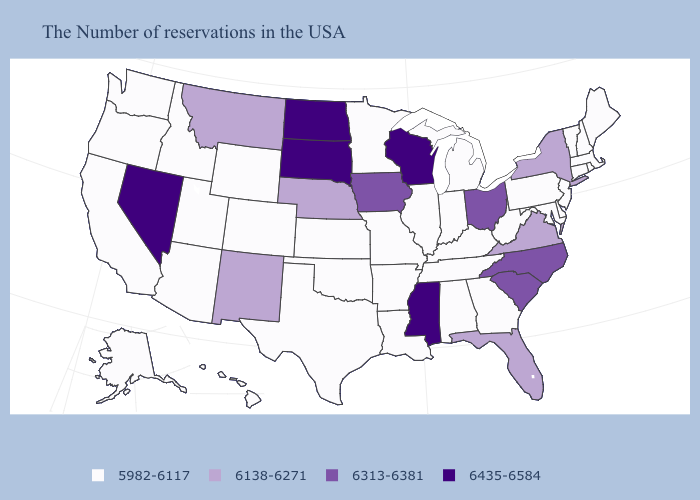Name the states that have a value in the range 5982-6117?
Keep it brief. Maine, Massachusetts, Rhode Island, New Hampshire, Vermont, Connecticut, New Jersey, Delaware, Maryland, Pennsylvania, West Virginia, Georgia, Michigan, Kentucky, Indiana, Alabama, Tennessee, Illinois, Louisiana, Missouri, Arkansas, Minnesota, Kansas, Oklahoma, Texas, Wyoming, Colorado, Utah, Arizona, Idaho, California, Washington, Oregon, Alaska, Hawaii. What is the lowest value in the USA?
Answer briefly. 5982-6117. Does New Mexico have the lowest value in the USA?
Concise answer only. No. Name the states that have a value in the range 6435-6584?
Give a very brief answer. Wisconsin, Mississippi, South Dakota, North Dakota, Nevada. Name the states that have a value in the range 6138-6271?
Give a very brief answer. New York, Virginia, Florida, Nebraska, New Mexico, Montana. What is the value of Texas?
Quick response, please. 5982-6117. Among the states that border Colorado , which have the lowest value?
Write a very short answer. Kansas, Oklahoma, Wyoming, Utah, Arizona. Which states hav the highest value in the South?
Short answer required. Mississippi. Among the states that border Vermont , does Massachusetts have the highest value?
Short answer required. No. Name the states that have a value in the range 6435-6584?
Keep it brief. Wisconsin, Mississippi, South Dakota, North Dakota, Nevada. Which states have the highest value in the USA?
Short answer required. Wisconsin, Mississippi, South Dakota, North Dakota, Nevada. Does the first symbol in the legend represent the smallest category?
Keep it brief. Yes. Name the states that have a value in the range 6313-6381?
Answer briefly. North Carolina, South Carolina, Ohio, Iowa. Among the states that border Rhode Island , which have the highest value?
Answer briefly. Massachusetts, Connecticut. Does Illinois have a higher value than Florida?
Give a very brief answer. No. 